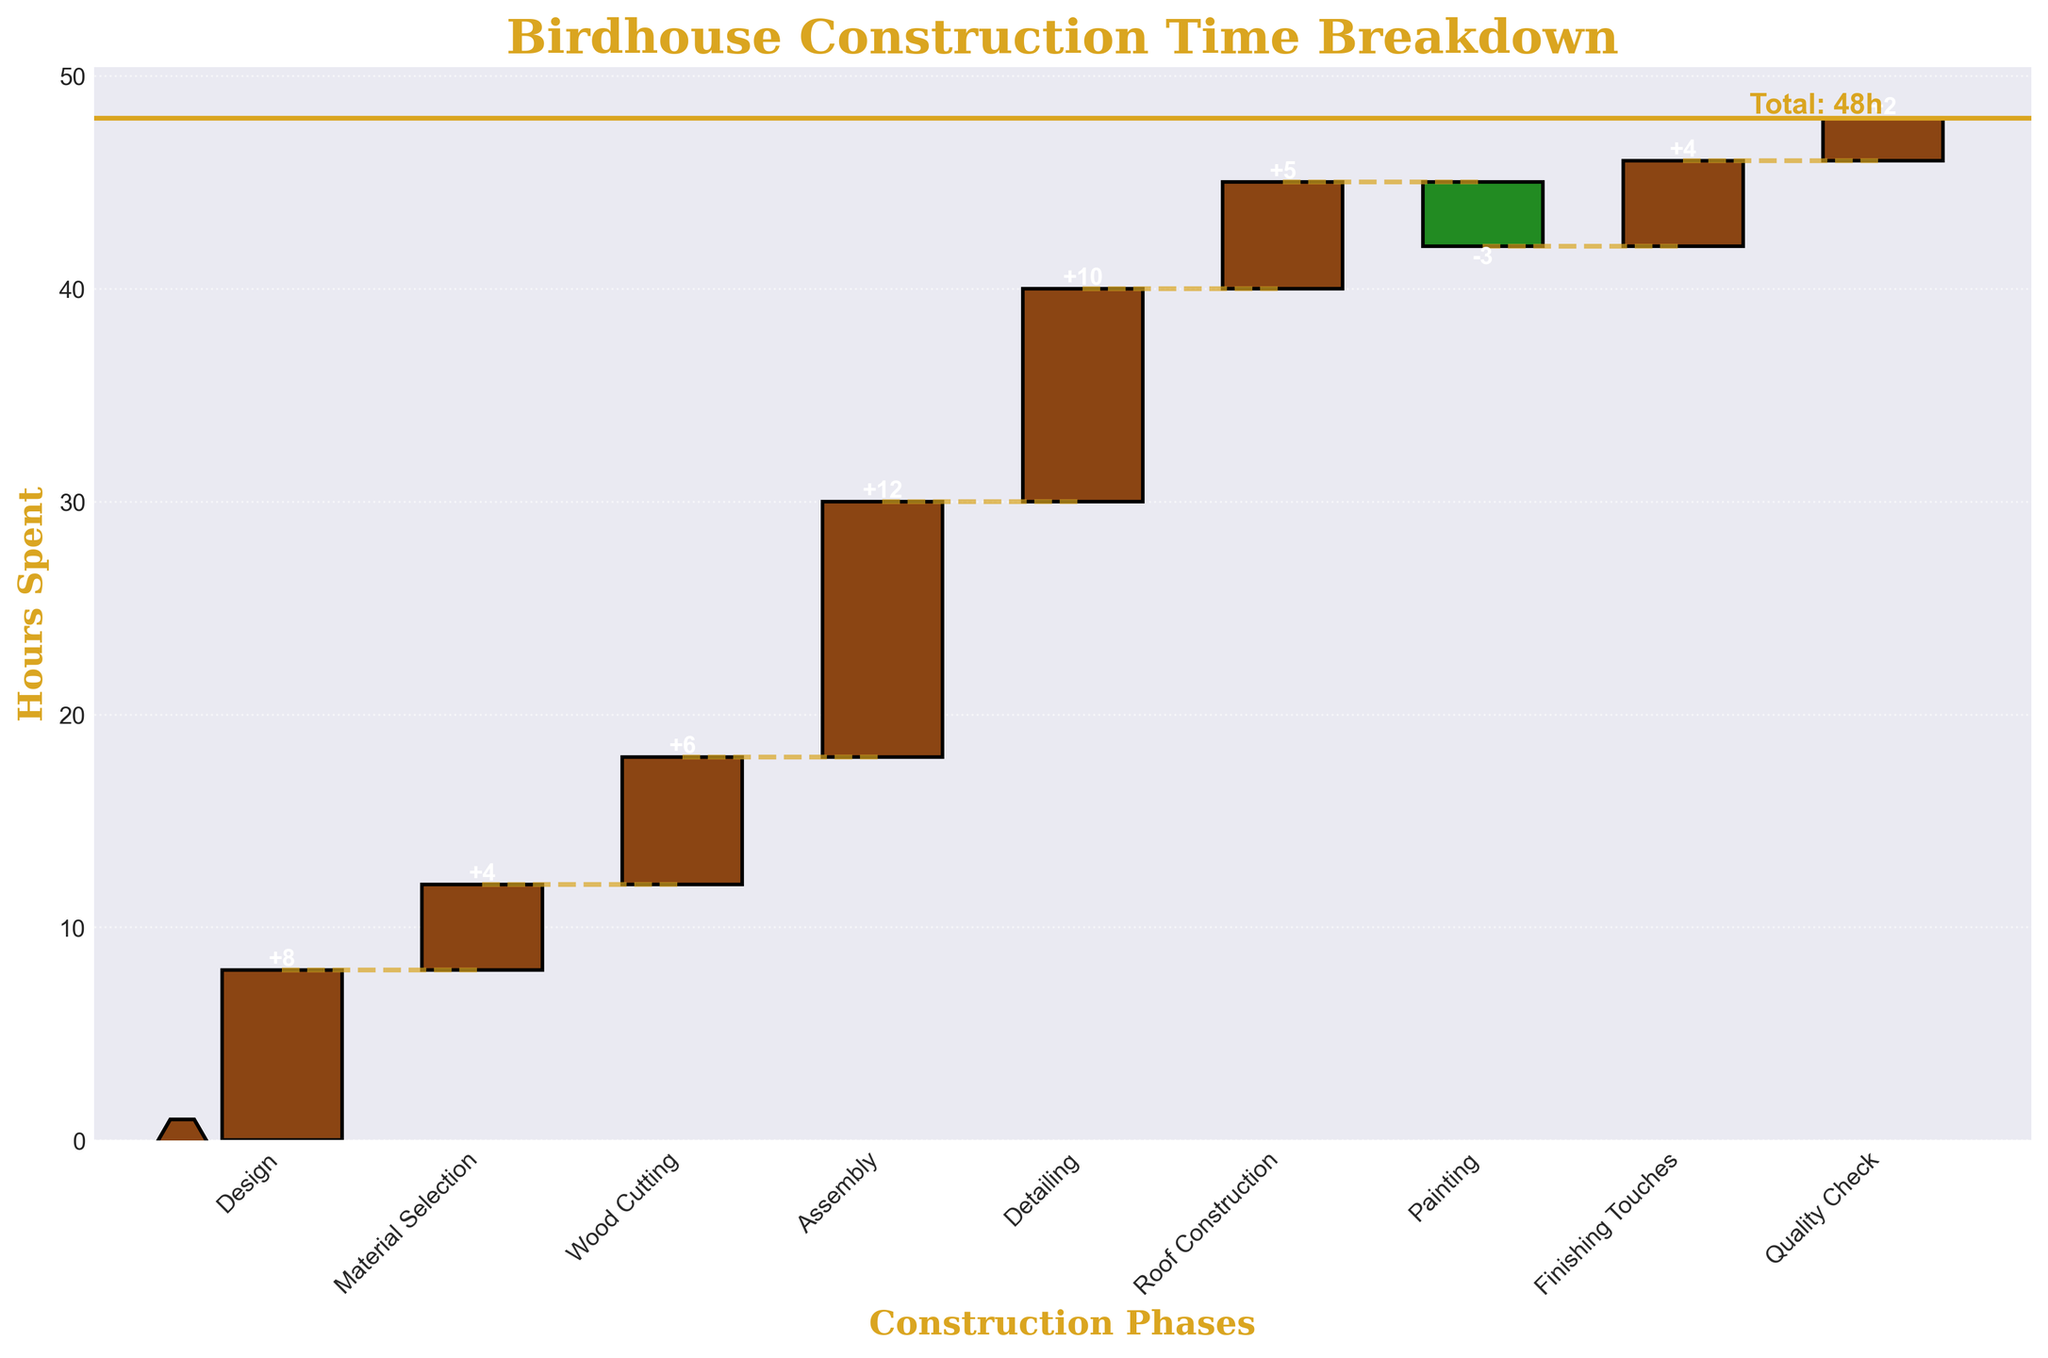What is the title of the chart? The title of a chart is usually written at the top of the figure. In this case, it is "Birdhouse Construction Time Breakdown" which can be clearly seen at the top of the chart.
Answer: Birdhouse Construction Time Breakdown How many phases are listed in the chart (excluding the total)? The number of phases can be determined by counting the labels on the x-axis. There are 9 labels corresponding to different phases excluding the total.
Answer: 9 What color indicates positive hours spent and what color indicates negative hours spent? In the chart, positive hours are represented by a brown color and negative hours (only painting in this case) are represented by a green color. These visual distinctions help in quickly identifying the nature of the contributions.
Answer: Brown and green How much time is spent on Assembly? The time spent on Assembly can be found by locating the Assembly phase on the x-axis and reading the labeled value on the bar. The number next to Assembly bar is +12 which implies 12 hours spent.
Answer: 12 hours Which phase took the least amount of positive time? To find the phase with the least amount of positive time, look at the lengths of all brown bars and find the smallest. Roof Construction has a +5 hours which is the smallest among the positive times.
Answer: Roof Construction What is the total time spent on birdhouse construction, as indicated in the chart? The total time is marked by a horizontal line across the chart, labeled "Total: 48h." It clearly states the total time spent, including all phases.
Answer: 48 hours What is the difference in hours spent between the phases of Design and Assembly? The time spent on Design is 8 hours, and for Assembly, it is 12 hours. The difference between these times is calculated as 12 - 8.
Answer: 4 hours How many hours were subtracted due to the Painting phase? The painting phase shows a green bar with a value of -3, indicating that 3 hours are subtracted during this phase.
Answer: 3 hours What is the cumulative time spent after the Detailing phase? The cumulative time after each phase can be determined by summing the hours up to that phase. The sums are: Design (8), Material Selection (8+4=12), Wood Cutting (12+6=18), Assembly (18+12=30), and Detailing (30+10=40).
Answer: 40 hours Which phase comes immediately after Wood Cutting, and how much time was spent on it? To find the phase after Wood Cutting, look at the x-axis labels in sequence. After Wood Cutting, the next phase is Assembly, and the time spent on this phase is 12 hours.
Answer: Assembly, 12 hours 